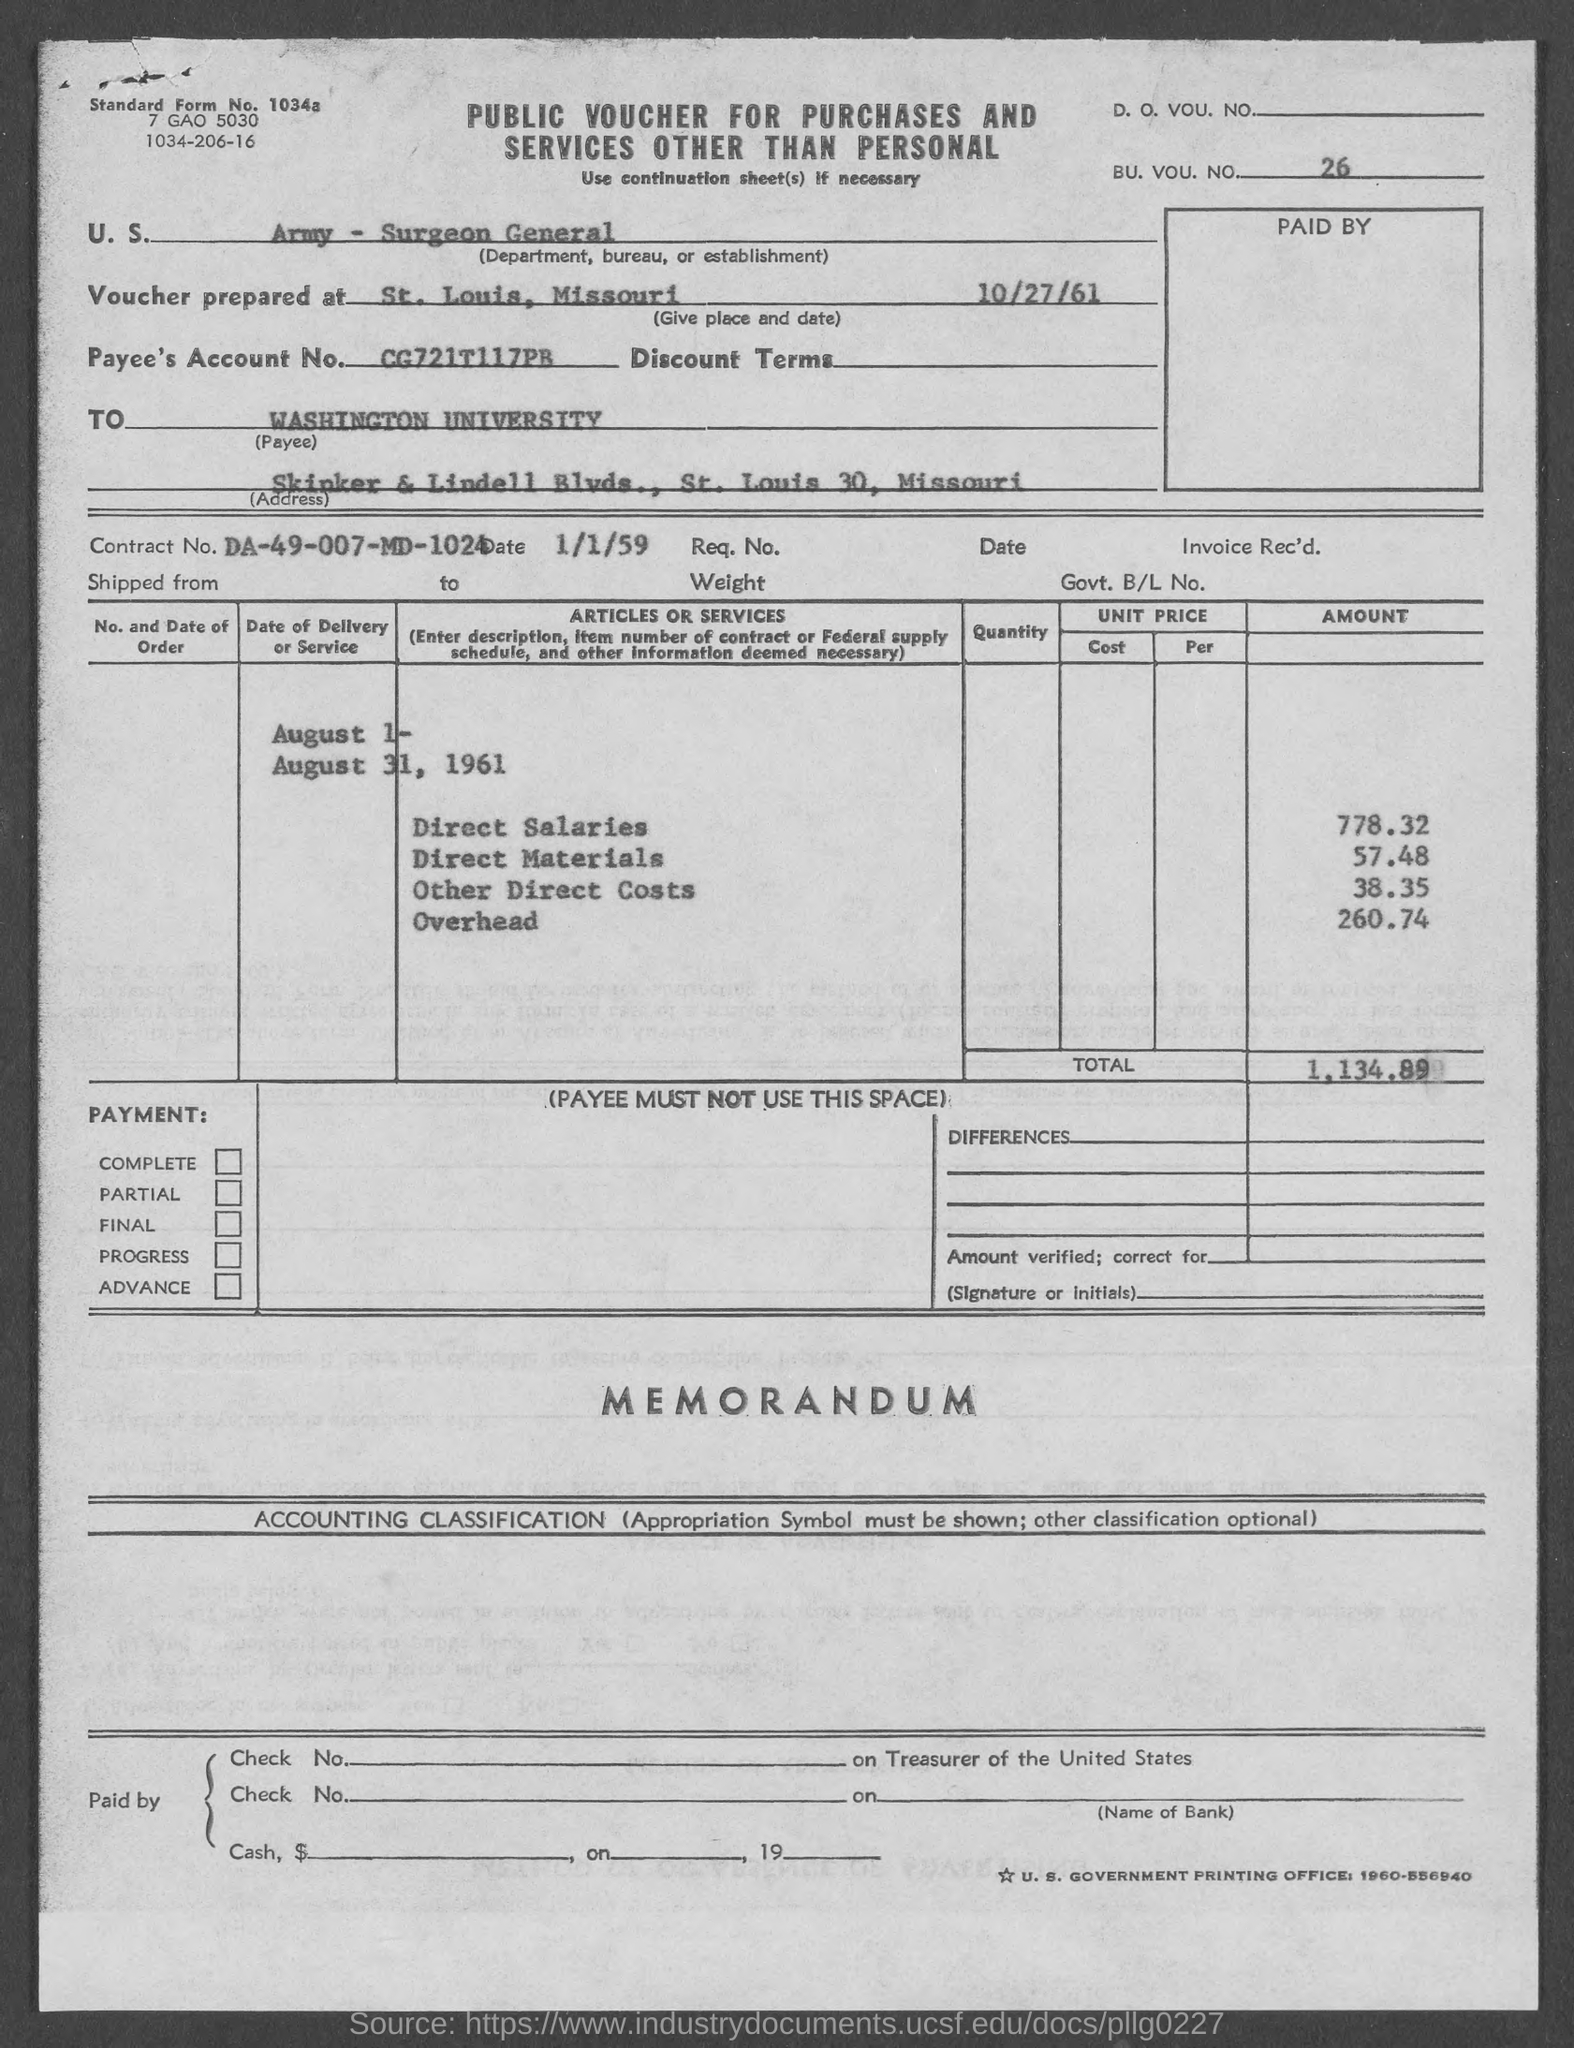What is the bu. vou. no.?
Keep it short and to the point. 26. In which state is washington university at?
Give a very brief answer. Missouri. What is the standard form no.?
Your answer should be compact. 1034a. What is the total ?
Keep it short and to the point. 1,134.89. What is the contract no.?
Provide a succinct answer. DA-49-007-MD-1024. What is the amount of direct salaries ?
Keep it short and to the point. 778.32. What is the amount of direct materials ?
Keep it short and to the point. 57.48. What is the amount of other direct costs?
Offer a terse response. 38.35. What is the amount of overhead ?
Offer a terse response. 260.74. 